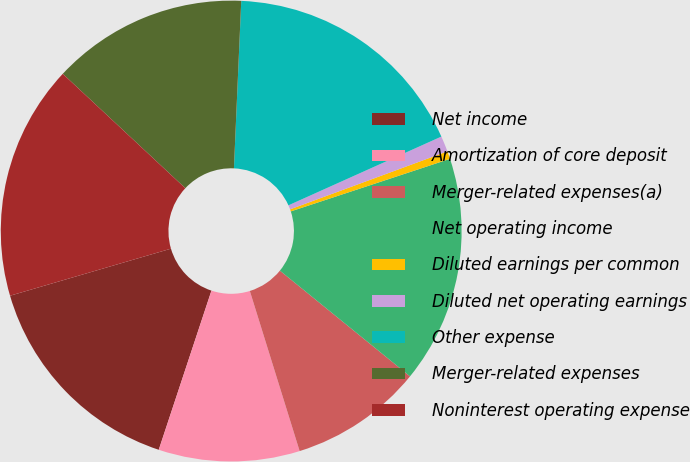<chart> <loc_0><loc_0><loc_500><loc_500><pie_chart><fcel>Net income<fcel>Amortization of core deposit<fcel>Merger-related expenses(a)<fcel>Net operating income<fcel>Diluted earnings per common<fcel>Diluted net operating earnings<fcel>Other expense<fcel>Merger-related expenses<fcel>Noninterest operating expense<nl><fcel>15.38%<fcel>9.89%<fcel>9.34%<fcel>15.93%<fcel>0.55%<fcel>1.1%<fcel>17.58%<fcel>13.74%<fcel>16.48%<nl></chart> 